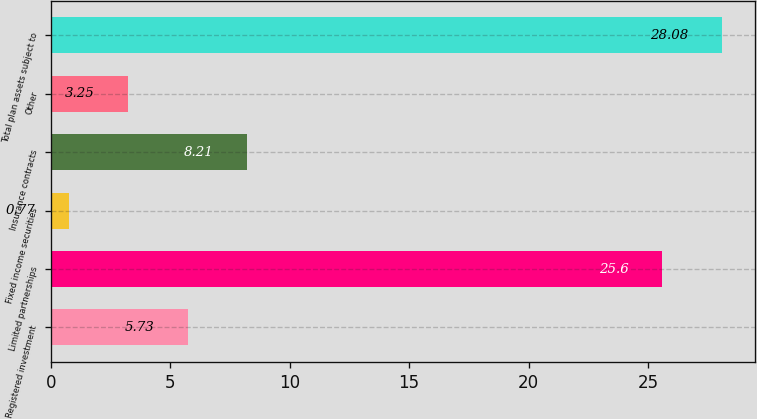Convert chart. <chart><loc_0><loc_0><loc_500><loc_500><bar_chart><fcel>Registered investment<fcel>Limited partnerships<fcel>Fixed income securities<fcel>Insurance contracts<fcel>Other<fcel>Total plan assets subject to<nl><fcel>5.73<fcel>25.6<fcel>0.77<fcel>8.21<fcel>3.25<fcel>28.08<nl></chart> 